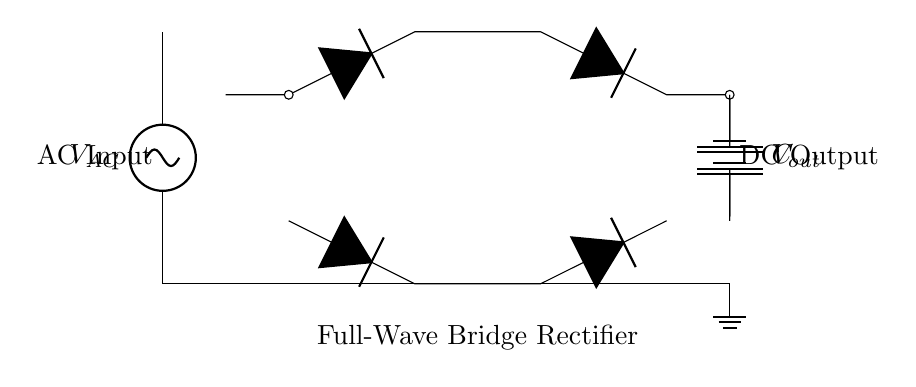What is the type of AC voltage source in this circuit? The circuit diagram shows an AC voltage source labeled as V_AC at the left. This indicates it is a source providing alternating current.
Answer: AC voltage source How many diodes are used in the bridge rectifier? The circuit diagram shows four diodes connected in a bridge configuration for full-wave rectification. This is typical for a full-wave bridge rectifier.
Answer: Four diodes What component is used to smooth the output voltage? The circuit includes a capacitor labeled C, which is used for smoothing the output voltage by filtering the rectified signal.
Answer: Capacitor What do the two lines connected to the battery represent? In the diagram, the two lines connecting to the battery represent the connections for DC output from the circuit to the battery, indicating the power supplied to it.
Answer: DC output connections What is the function of the load resistor in this circuit? In battery charger circuits like this one, the load resistor is often a battery, acting as a load that will be charged by the output of the rectifier.
Answer: Battery How does the bridge rectifier convert AC to DC? The bridge rectifier uses four diodes arranged to allow both halves of the AC waveform to be utilized, effectively converting the AC into a pulsating DC signal through the diodes' conduction in alternating directions.
Answer: Converts AC to DC What is the significance of the smoothing capacitor in this circuit? The smoothing capacitor charges during the peaks of the output voltage and discharges when the voltage drops, helping to maintain a stable DC voltage level at the output, reducing ripples.
Answer: Stabilizes DC voltage 